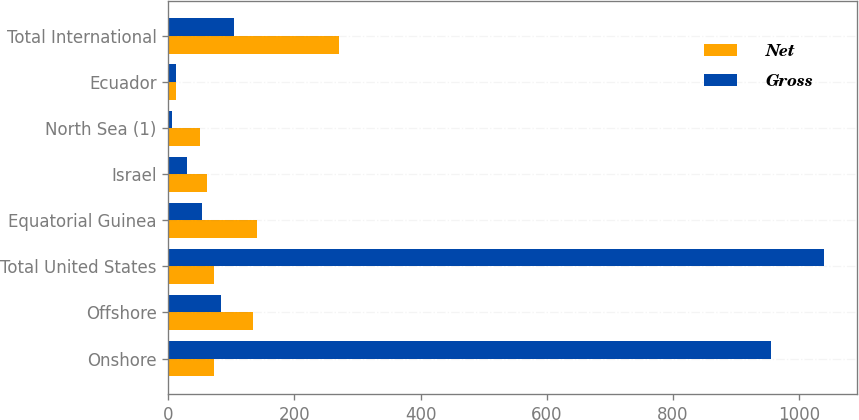Convert chart to OTSL. <chart><loc_0><loc_0><loc_500><loc_500><stacked_bar_chart><ecel><fcel>Onshore<fcel>Offshore<fcel>Total United States<fcel>Equatorial Guinea<fcel>Israel<fcel>North Sea (1)<fcel>Ecuador<fcel>Total International<nl><fcel>Net<fcel>73<fcel>134<fcel>73<fcel>140<fcel>62<fcel>50<fcel>12<fcel>271<nl><fcel>Gross<fcel>956<fcel>84<fcel>1040<fcel>53<fcel>29<fcel>6<fcel>12<fcel>104<nl></chart> 